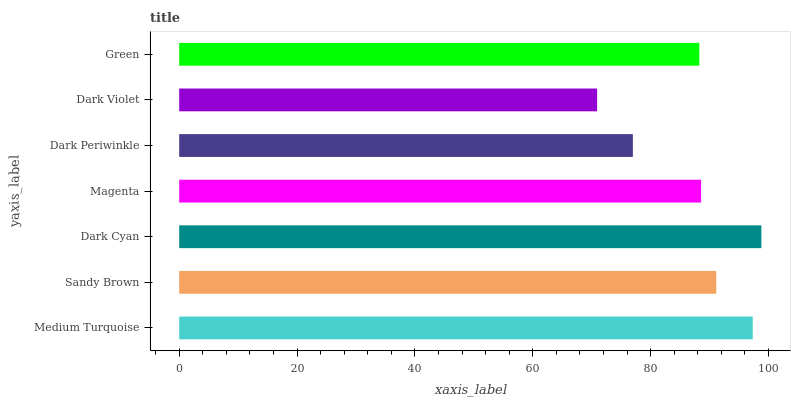Is Dark Violet the minimum?
Answer yes or no. Yes. Is Dark Cyan the maximum?
Answer yes or no. Yes. Is Sandy Brown the minimum?
Answer yes or no. No. Is Sandy Brown the maximum?
Answer yes or no. No. Is Medium Turquoise greater than Sandy Brown?
Answer yes or no. Yes. Is Sandy Brown less than Medium Turquoise?
Answer yes or no. Yes. Is Sandy Brown greater than Medium Turquoise?
Answer yes or no. No. Is Medium Turquoise less than Sandy Brown?
Answer yes or no. No. Is Magenta the high median?
Answer yes or no. Yes. Is Magenta the low median?
Answer yes or no. Yes. Is Dark Periwinkle the high median?
Answer yes or no. No. Is Dark Cyan the low median?
Answer yes or no. No. 